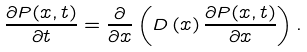<formula> <loc_0><loc_0><loc_500><loc_500>\frac { \partial P ( x , t ) } { \partial t } = \frac { \partial } { \partial x } \left ( D \left ( x \right ) \frac { \partial P ( x , t ) } { \partial x } \right ) .</formula> 